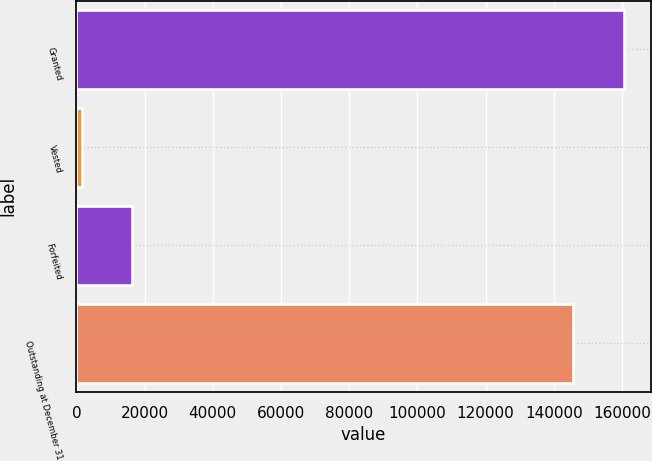Convert chart to OTSL. <chart><loc_0><loc_0><loc_500><loc_500><bar_chart><fcel>Granted<fcel>Vested<fcel>Forfeited<fcel>Outstanding at December 31<nl><fcel>160500<fcel>1523<fcel>16389.4<fcel>145634<nl></chart> 